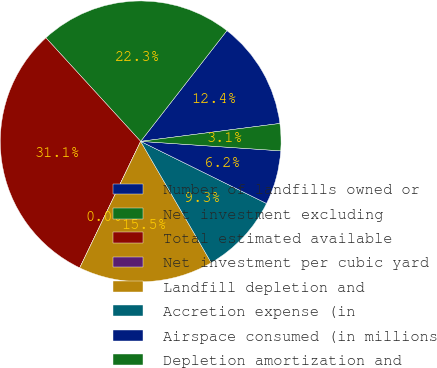Convert chart to OTSL. <chart><loc_0><loc_0><loc_500><loc_500><pie_chart><fcel>Number of landfills owned or<fcel>Net investment excluding<fcel>Total estimated available<fcel>Net investment per cubic yard<fcel>Landfill depletion and<fcel>Accretion expense (in<fcel>Airspace consumed (in millions<fcel>Depletion amortization and<nl><fcel>12.43%<fcel>22.33%<fcel>31.06%<fcel>0.0%<fcel>15.53%<fcel>9.32%<fcel>6.22%<fcel>3.11%<nl></chart> 